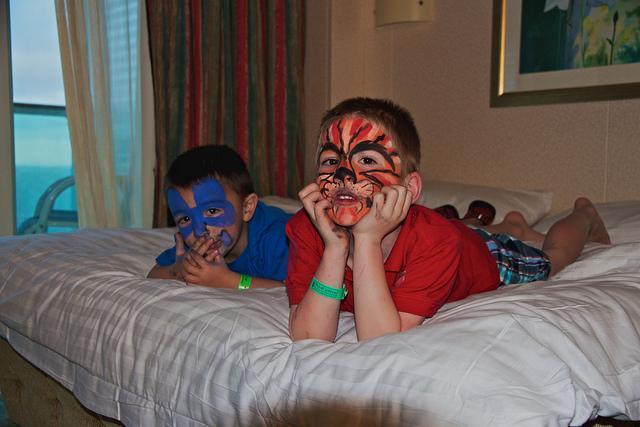How many curtains are there?
Give a very brief answer. 2. How many people laying on the bed?
Give a very brief answer. 2. How many white pillows are there?
Give a very brief answer. 1. How many people are in the photo?
Give a very brief answer. 2. 